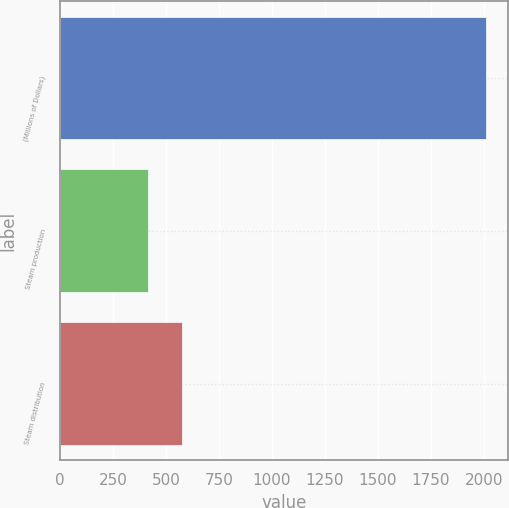Convert chart. <chart><loc_0><loc_0><loc_500><loc_500><bar_chart><fcel>(Millions of Dollars)<fcel>Steam production<fcel>Steam distribution<nl><fcel>2011<fcel>415<fcel>574.6<nl></chart> 